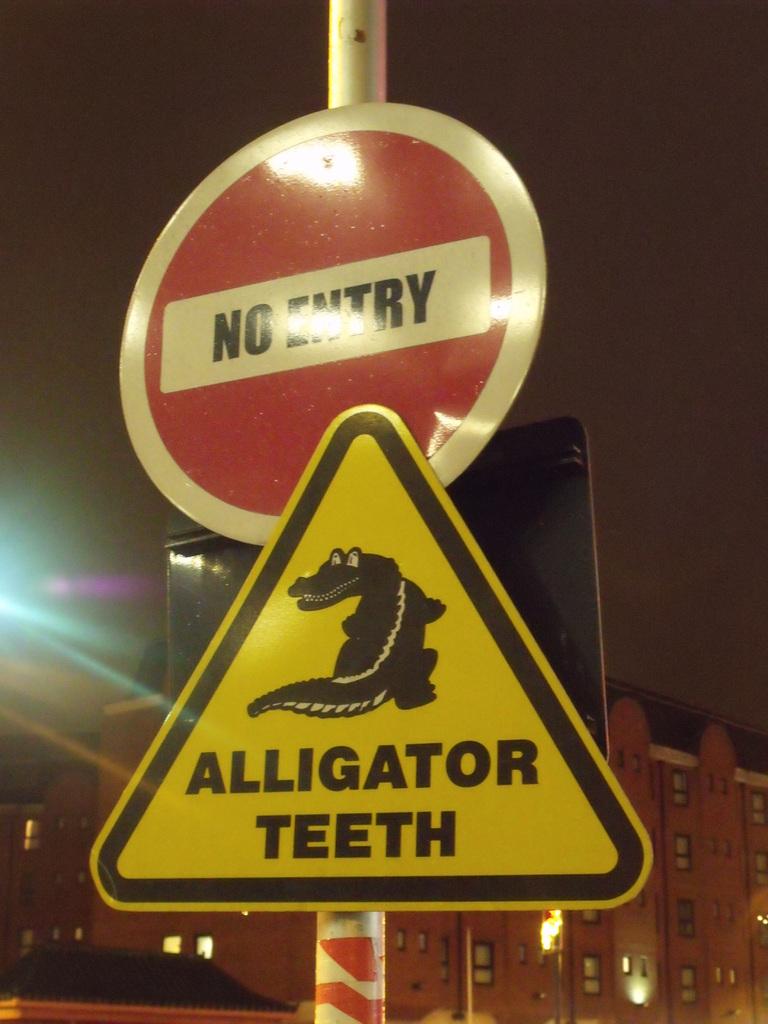What does the red and white sign warn?
Give a very brief answer. No entry. What type of teeth?
Keep it short and to the point. Alligator. 